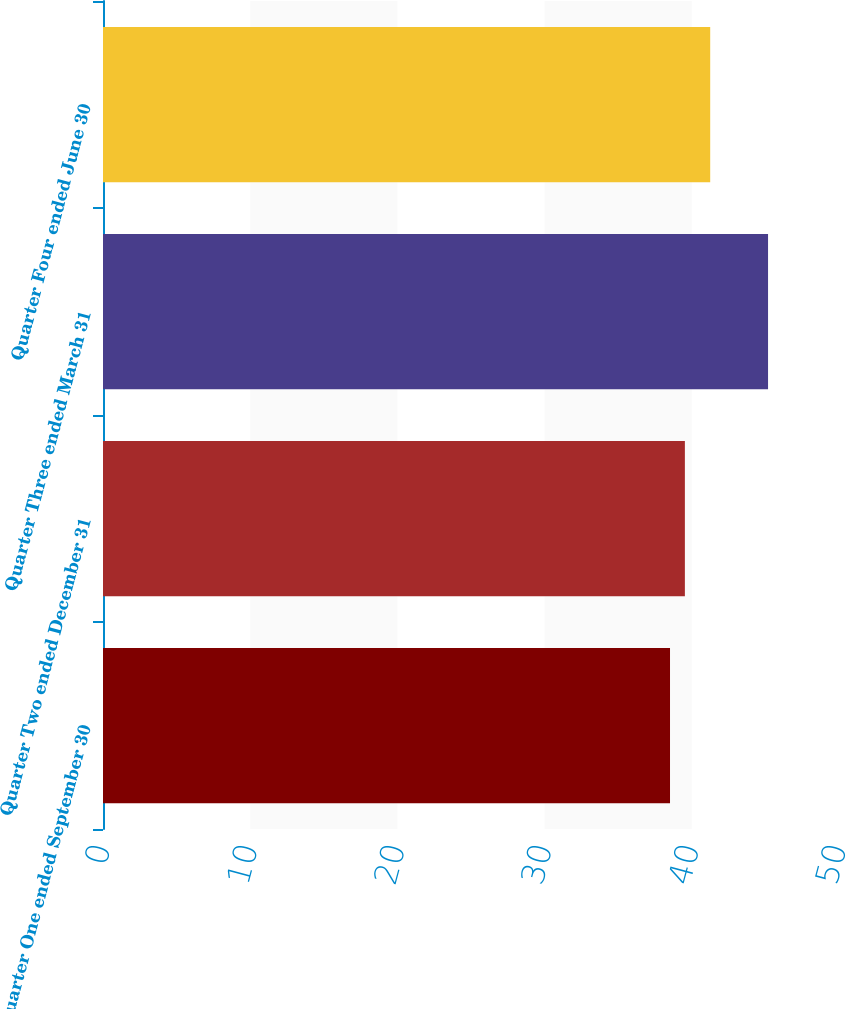Convert chart. <chart><loc_0><loc_0><loc_500><loc_500><bar_chart><fcel>Quarter One ended September 30<fcel>Quarter Two ended December 31<fcel>Quarter Three ended March 31<fcel>Quarter Four ended June 30<nl><fcel>38.52<fcel>39.53<fcel>45.18<fcel>41.25<nl></chart> 